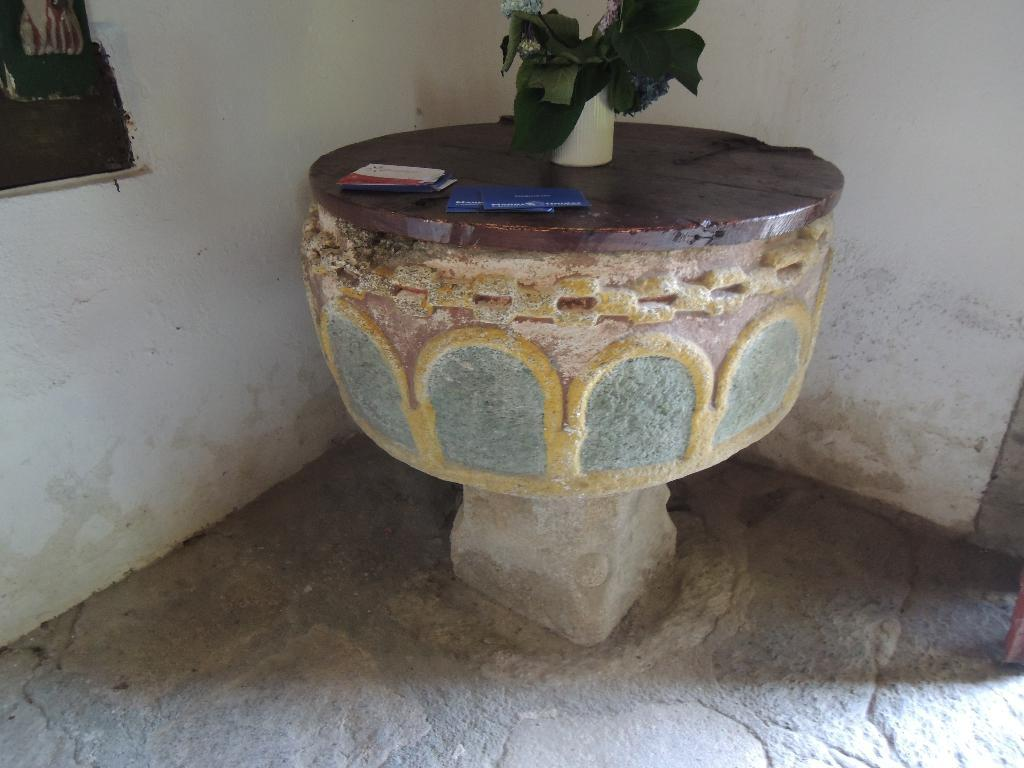What object can be seen in the image that is typically used for holding flowers? There is a flower vase in the image. What is placed on the concrete platform in the image? Papers are placed on the concrete platform in the image. What can be seen in the background of the image? There is a wall and a curtain on a window in the background of the image. What type of cake is being served on the concrete platform in the image? There is no cake present in the image; it features a flower vase and papers on a concrete platform. How many thumbs can be seen interacting with the papers in the image? There is no thumb visible in the image, as it focuses on the flower vase, papers, and the background. 